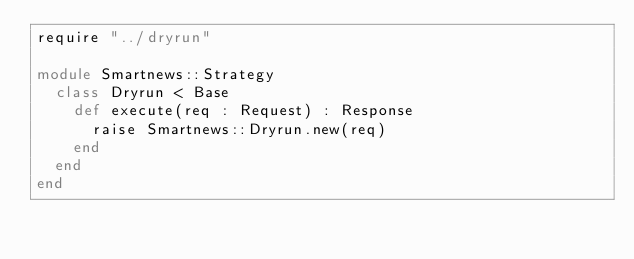<code> <loc_0><loc_0><loc_500><loc_500><_Crystal_>require "../dryrun"

module Smartnews::Strategy
  class Dryrun < Base
    def execute(req : Request) : Response
      raise Smartnews::Dryrun.new(req)
    end
  end
end
</code> 